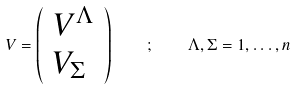Convert formula to latex. <formula><loc_0><loc_0><loc_500><loc_500>V = \left ( \begin{array} { c } V ^ { \Lambda } \\ V _ { \Sigma } \ \end{array} \right ) \quad ; \quad \Lambda , \Sigma = 1 , \dots , n</formula> 